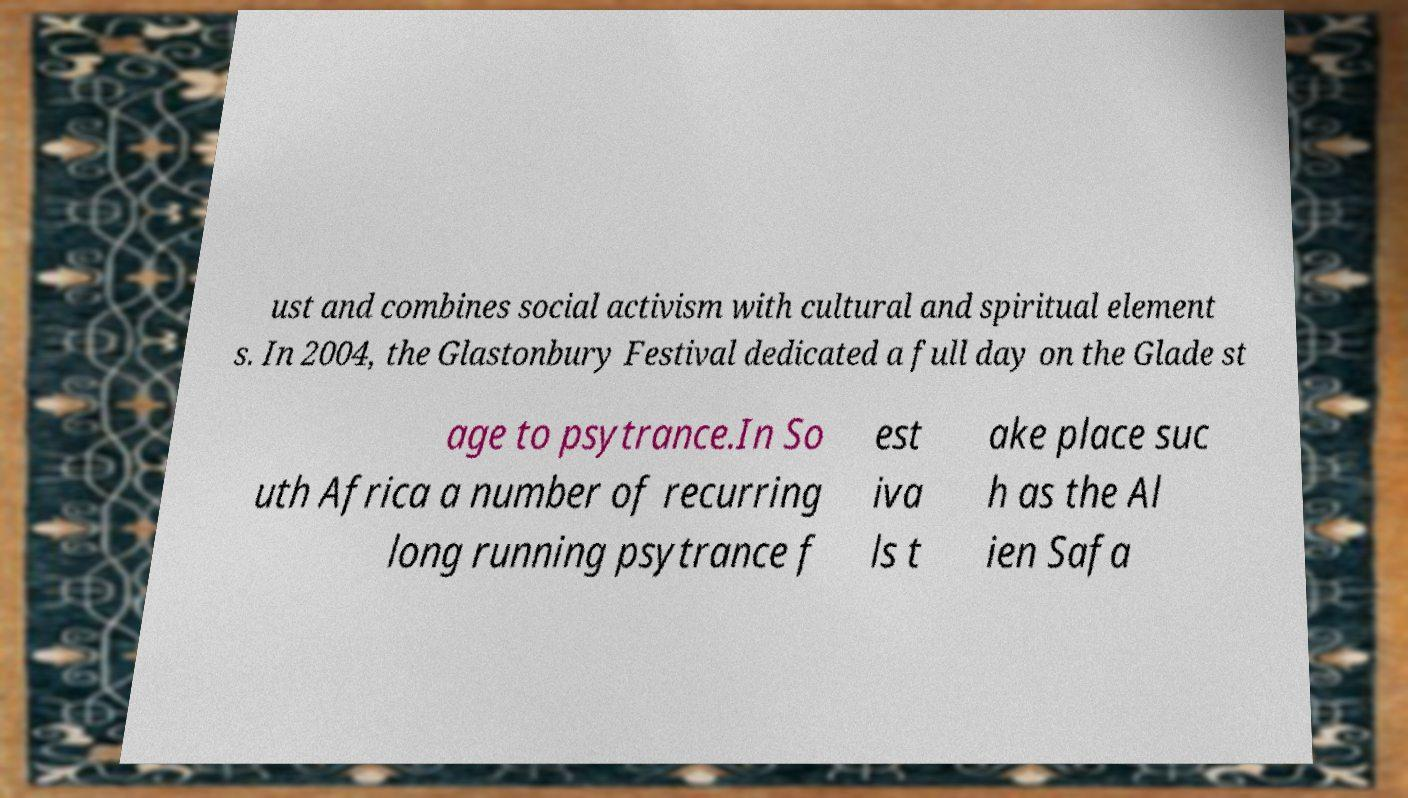Please read and relay the text visible in this image. What does it say? ust and combines social activism with cultural and spiritual element s. In 2004, the Glastonbury Festival dedicated a full day on the Glade st age to psytrance.In So uth Africa a number of recurring long running psytrance f est iva ls t ake place suc h as the Al ien Safa 